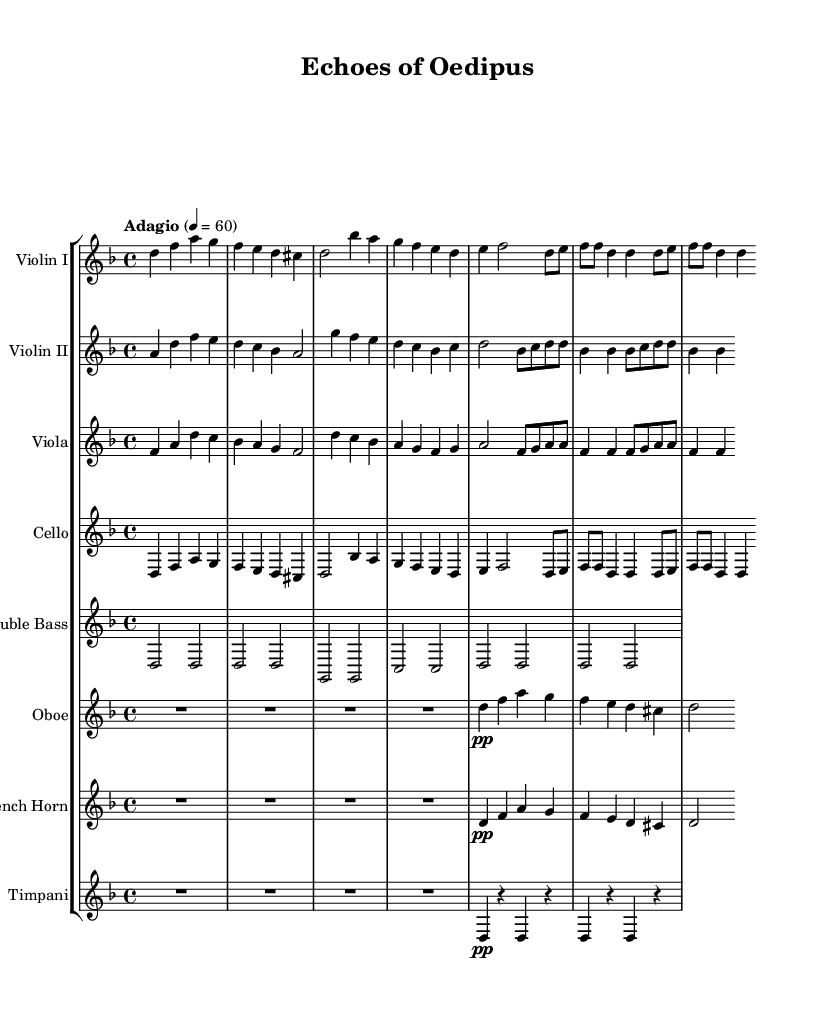What is the key signature of this music? The key signature is indicated by the sharps or flats shown at the beginning of the staff. In this case, the absence of any sharps or flats points to D minor.
Answer: D minor What is the time signature of the music? The time signature is represented as a fraction indicating how many beats are in a measure. It is shown at the beginning of the staff as 4 over 4, which means there are four beats per measure.
Answer: 4/4 What is the tempo marking of this piece? The tempo marking is generally provided at the beginning of the sheet music, indicating the speed of the piece. "Adagio" means a slow tempo, with a metronome indication of 60.
Answer: Adagio How many measures are in the violin I part? To find the number of measures, count the measures marked by vertical lines in the violin I part. Counting the measures gives a total of eight measures.
Answer: Eight Which instruments are featured in this symphony? The instruments are listed at the start of each staff in the sheet music. Observing the ensemble includes violins, viola, cello, double bass, oboe, French horn, and timpani.
Answer: Violins, viola, cello, double bass, oboe, French horn, timpani What style does this symphony reflect based on its content? The overall mood, use of harmonies, and instrumentation suggest that it reflects dramatic and emotional arcs similar to those found in classical tragedies. This relates to the piece's name, "Echoes of Oedipus."
Answer: Dramatic symphonic What is the dynamic marking for the oboe part? Dynamic markings are notated in the sheet music; the oboe part has a marking indicating "pp," denoting it should be played very softly or pianissimo.
Answer: pp 